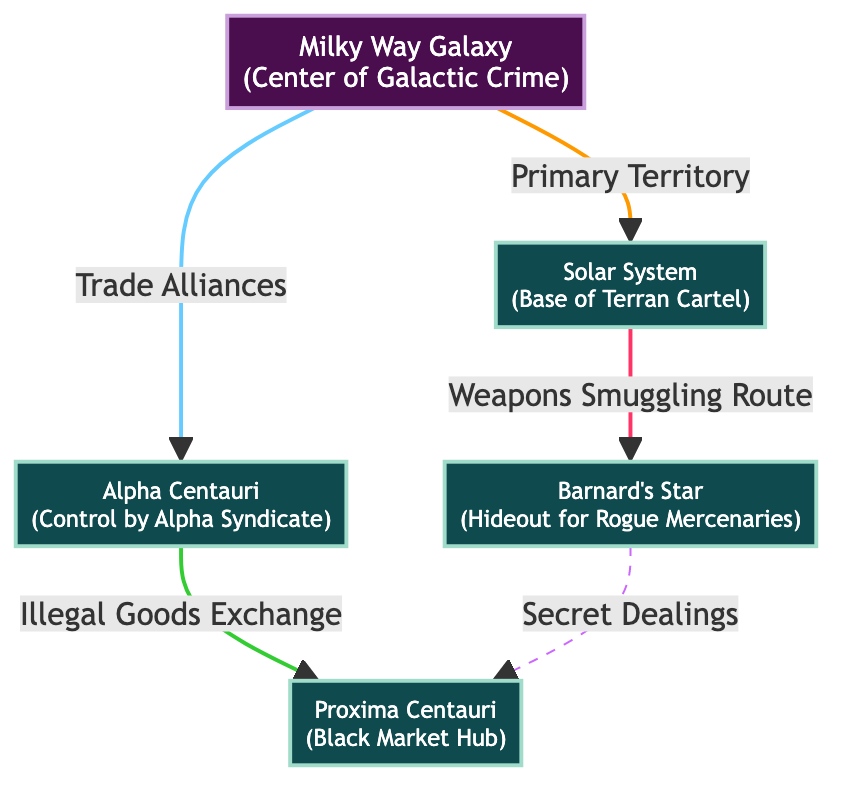What is the primary territory of the Milky Way Galaxy? The diagram shows that the Milky Way Galaxy has a primary territory that includes the Solar System. This information can be directly inferred from the connection labeled "Primary Territory" that points from the Milky Way Galaxy node to the Solar System node.
Answer: Solar System How many systems are connected to the Milky Way Galaxy? The diagram indicates that there are three systems connected to the Milky Way Galaxy: the Solar System, Alpha Centauri, and Barnard's Star. The connections can be counted by observing the arrows pointing from the Milky Way Galaxy to these systems.
Answer: 3 Which system is controlled by the Alpha Syndicate? The Alpha Centauri system is indicated as being controlled by the Alpha Syndicate in the diagram. This information is clearly detailed next to the Alpha Centauri node.
Answer: Alpha Centauri What type of route connects the Solar System to Barnard's Star? The connection labeled "Weapons Smuggling Route" between the Solar System and Barnard's Star signifies the type of route present. By reading this label, it is clear what kind of route is being referenced.
Answer: Weapons Smuggling Route How many secret dealings are illustrated between Barnard's Star and Proxima Centauri? The diagram shows a single dashed line labeled "Secret Dealings" that connects Barnard's Star to Proxima Centauri, indicating that there is one such dealings connection between these two systems.
Answer: 1 What is the black market hub located in Proxima Centauri? The diagram specifies that Proxima Centauri serves as a Black Market Hub. The description next to the Proxima Centauri node provides this information explicitly.
Answer: Black Market Hub What type of relationship exists between Alpha Centauri and Proxima Centauri? The diagram describes the connection between Alpha Centauri and Proxima Centauri as an "Illegal Goods Exchange." This can be derived by observing the label on the connecting arrow between these two systems.
Answer: Illegal Goods Exchange Which system serves as a hideout for rogue mercenaries? The diagram indicates that Barnard's Star functions as a hideout for rogue mercenaries. This information is part of the description associated with the Barnard's Star node.
Answer: Barnard's Star 